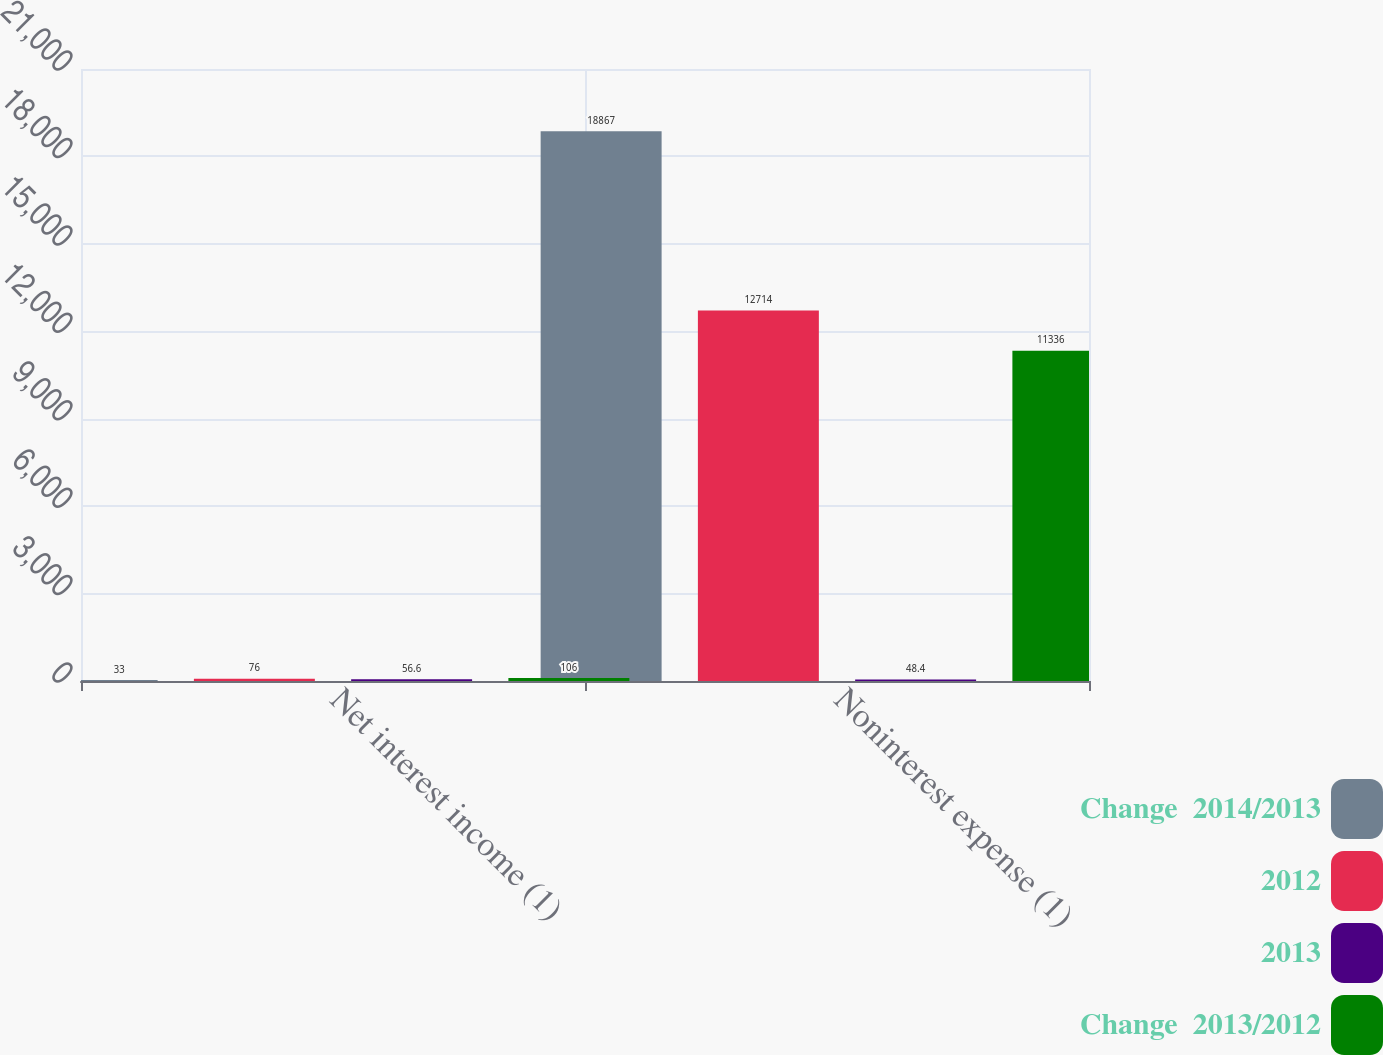Convert chart to OTSL. <chart><loc_0><loc_0><loc_500><loc_500><stacked_bar_chart><ecel><fcel>Net interest income (1)<fcel>Noninterest expense (1)<nl><fcel>Change  2014/2013<fcel>33<fcel>18867<nl><fcel>2012<fcel>76<fcel>12714<nl><fcel>2013<fcel>56.6<fcel>48.4<nl><fcel>Change  2013/2012<fcel>106<fcel>11336<nl></chart> 